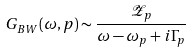<formula> <loc_0><loc_0><loc_500><loc_500>G _ { B W } ( \omega , p ) \sim \frac { \mathcal { Z } _ { p } } { \omega - \omega _ { p } + i \Gamma _ { p } }</formula> 